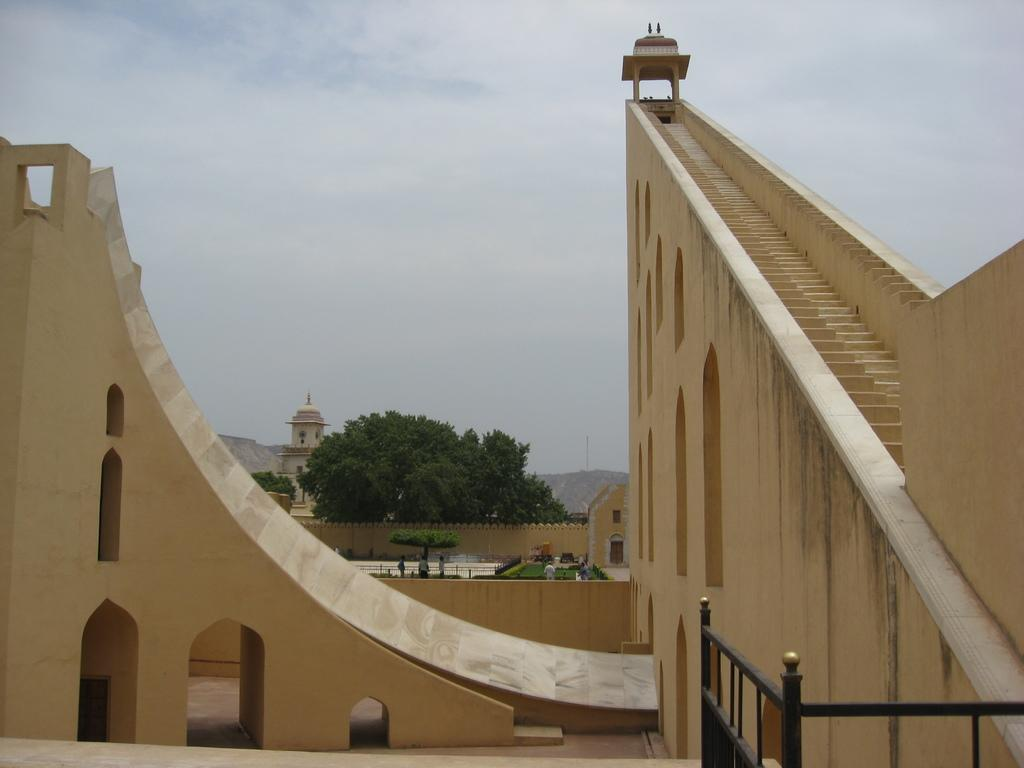What structures can be seen in the image? There are buildings in the image. What type of natural elements can be seen in the background of the image? There are trees and clouds in the sky in the background of the image. How many dinosaurs can be seen in the image? There are no dinosaurs present in the image. What type of bike is visible in the image? There is no bike present in the image. 